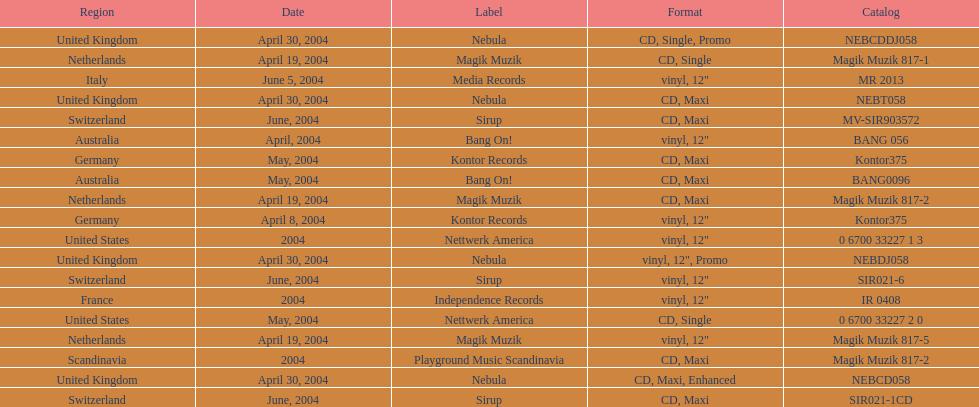What label was the only label to be used by france? Independence Records. 